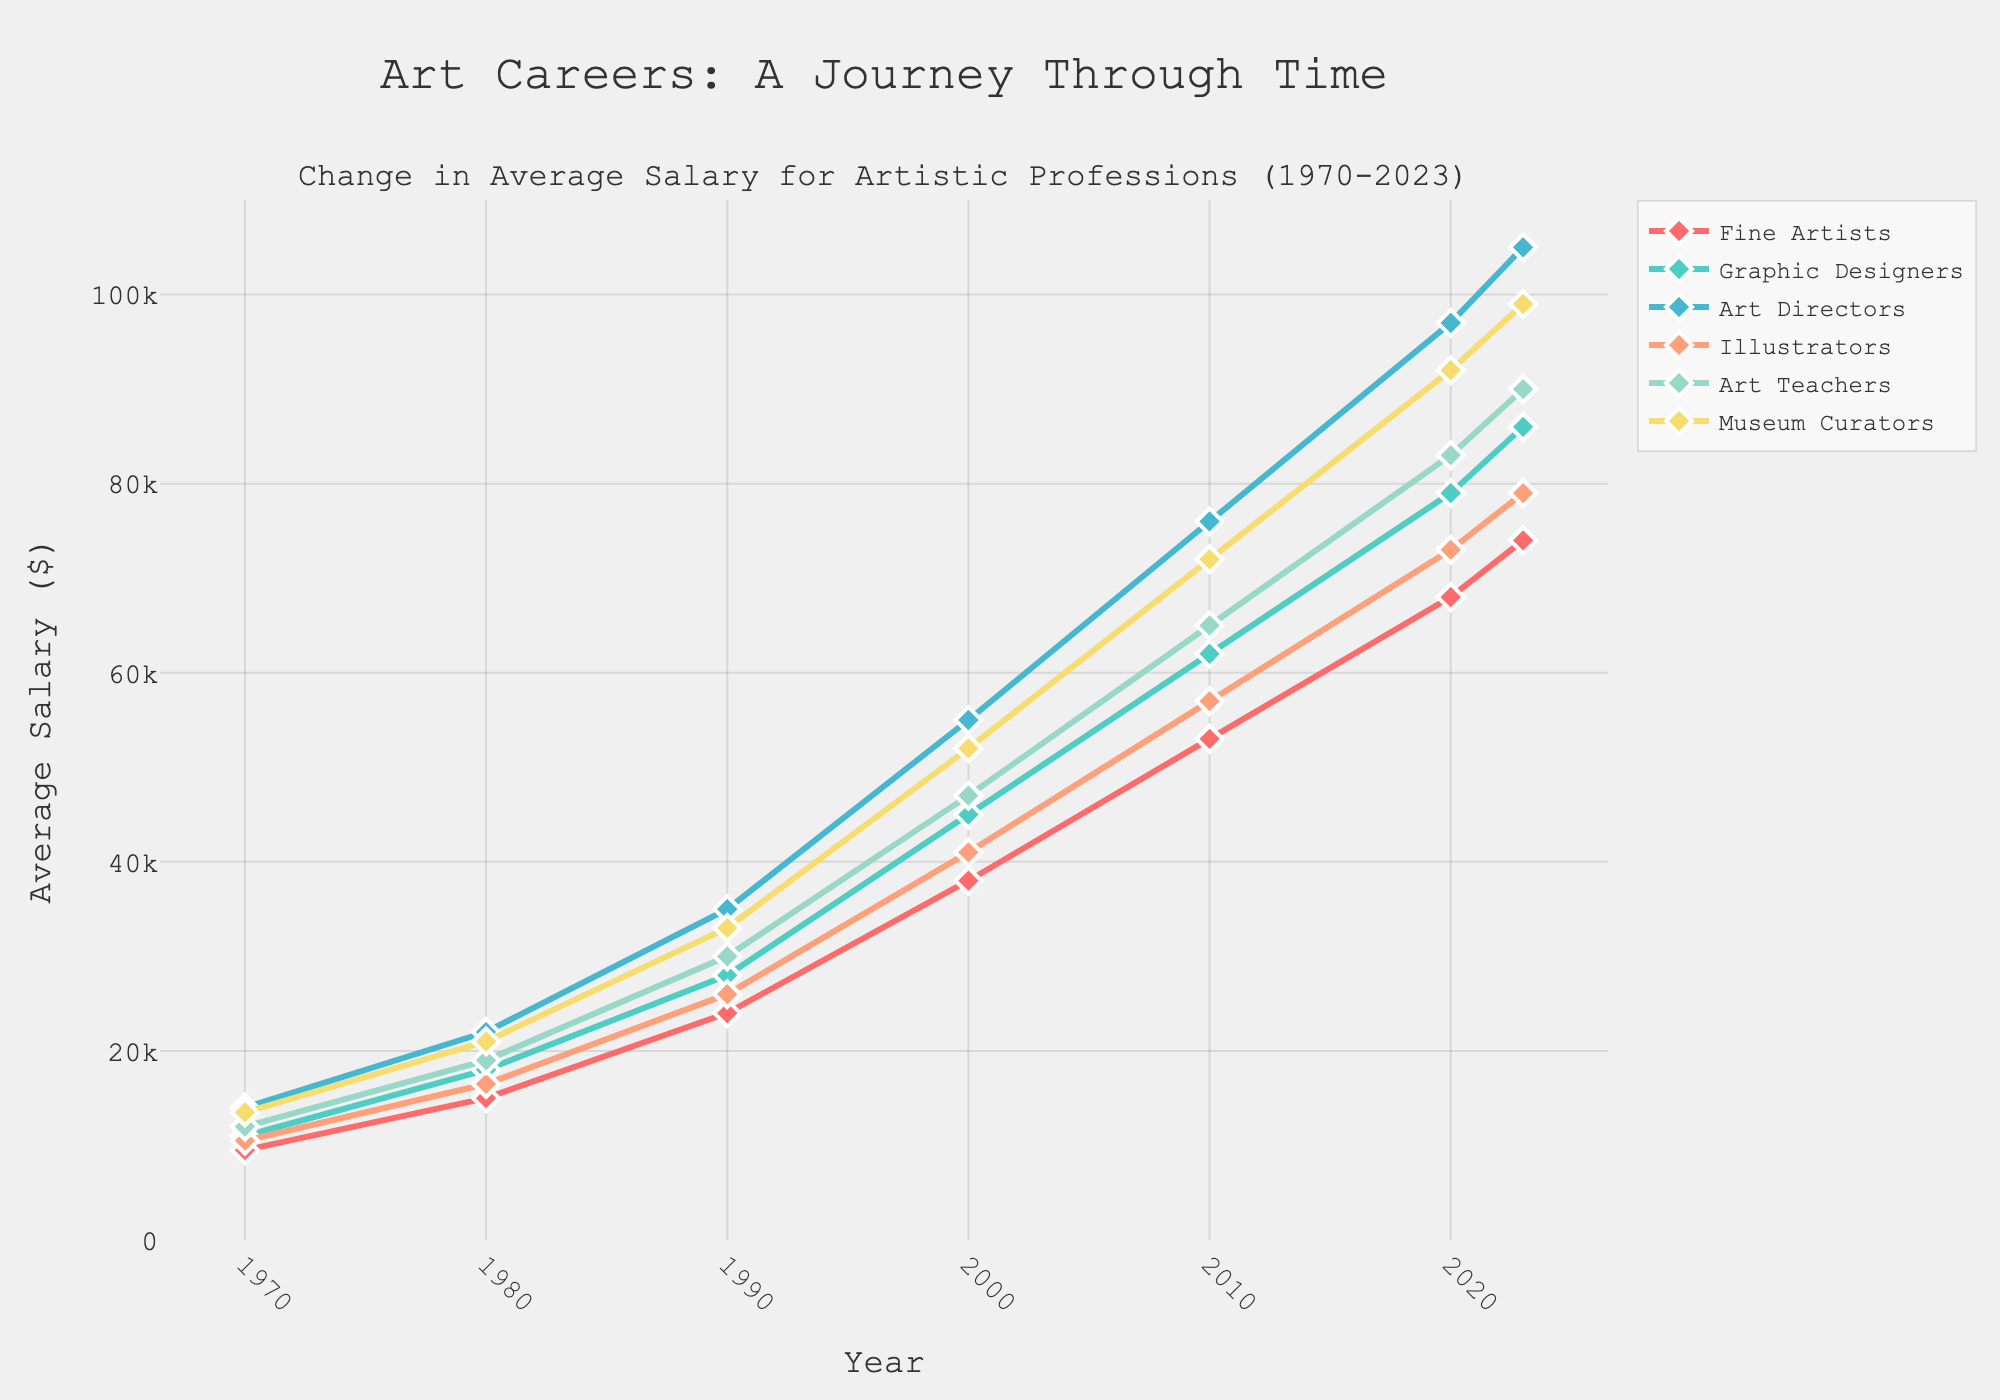Which artistic profession had the highest average salary in 2023? To find the highest average salary in 2023, look at the final data points in the figure. The Art Directors had the highest end value.
Answer: Art Directors How much more did Fine Artists earn in 2020 compared to 1970? Subtract the average salary of Fine Artists in 1970 from their salary in 2020: 68000 - 9500 = 58500.
Answer: 58500 Which profession showed the most significant increase in average salary from 1970 to 2023? Determine the difference between 2023 and 1970 for all professions and compare them. The difference for Art Directors is the largest: 105000 - 14000 = 91000.
Answer: Art Directors What is the trend of the average salary for Museum Curators over the years? Observe the line corresponding to Museum Curators. The trend shows a consistent increase from 1970 to 2023.
Answer: Increasing How does the average salary of Graphic Designers in 2010 compare to that of Art Teachers in 2010? Compare the two salaries: 62000 for Graphic Designers and 65000 for Art Teachers.
Answer: Art Teachers earned more By how much has the salary for Illustrators increased from 1980 to 2023? Subtract the 1980 value from the 2023 value for Illustrators: 79000 - 16500 = 62500.
Answer: 62500 Which profession experienced the smallest salary growth from 1970 to 2023? Calculate the growth for each profession and find the smallest increase. Fine Artists have the smallest increase: 74000 - 9500 = 64500.
Answer: Fine Artists What are the colors used to represent different professions in the figure, and which profession does each color correspond to? One must identify the colors and match them with the profession they represent. The exact colors based on the order and visual inspection are: Fine Artists (red), Graphic Designers (teal), Art Directors (blue), Illustrators (orange), Art Teachers (light green), Museum Curators (yellow).
Answer: Red (Fine Artists), Teal (Graphic Designers), Blue (Art Directors), Orange (Illustrators), Light Green (Art Teachers), Yellow (Museum Curators) What is the average salary of all professions combined in the year 2000? Calculate the sum of all professions' salaries in 2000 and then the average: (38000 + 45000 + 55000 + 41000 + 47000 + 52000) / 6 = 46333.33.
Answer: 46333.33 Which two professions had the closest average salaries in 1990? Compare the 1990 salaries to find the smallest difference between two values: the salaries for Art Teachers (30000) and Museum Curators (33000) are closest with a difference of 3000.
Answer: Art Teachers and Museum Curators 